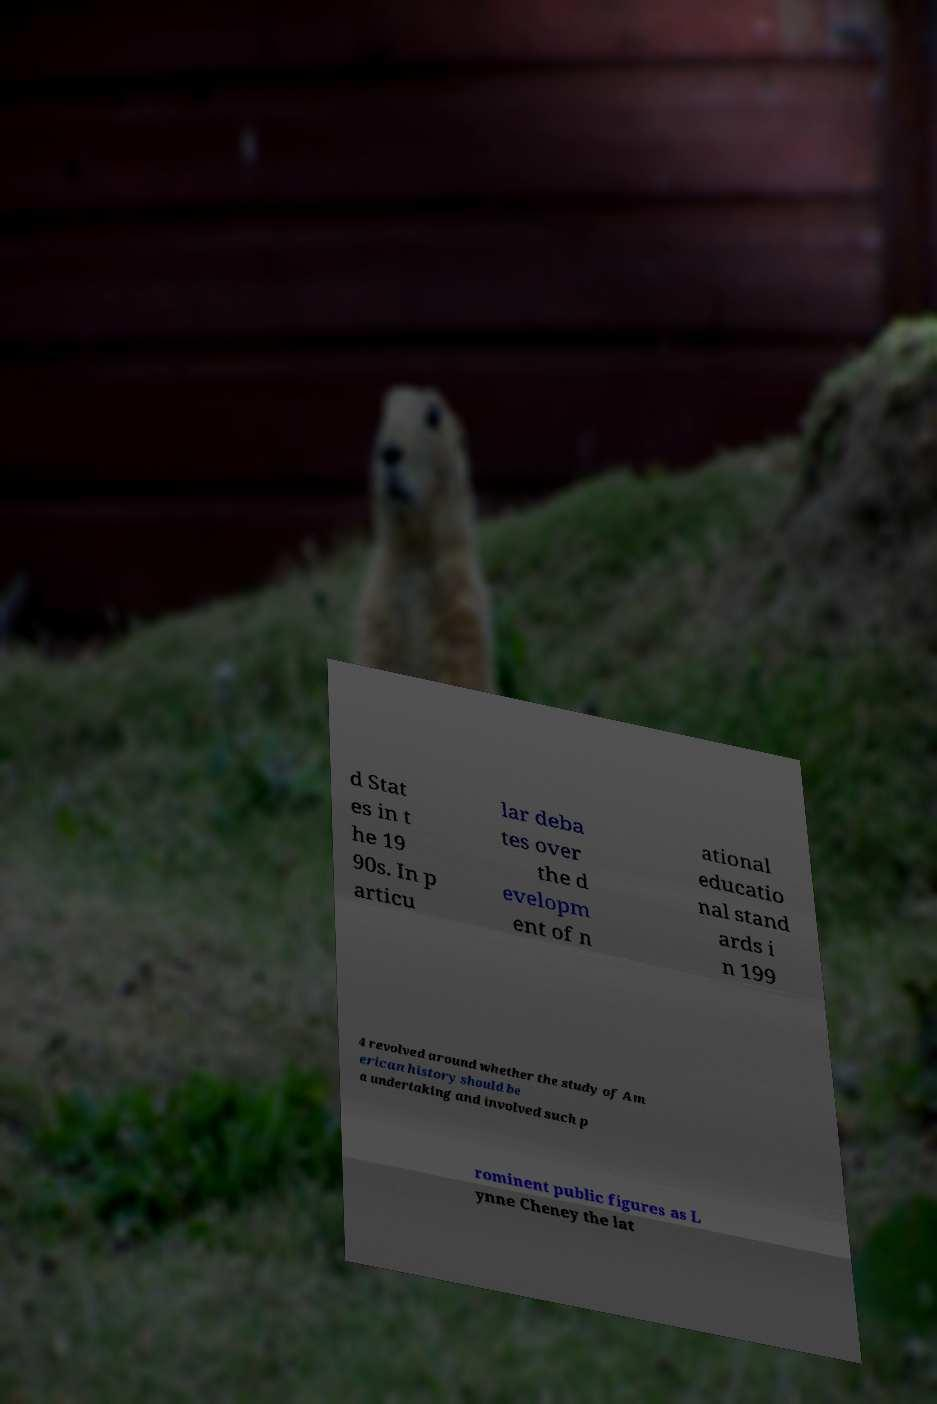Can you read and provide the text displayed in the image?This photo seems to have some interesting text. Can you extract and type it out for me? d Stat es in t he 19 90s. In p articu lar deba tes over the d evelopm ent of n ational educatio nal stand ards i n 199 4 revolved around whether the study of Am erican history should be a undertaking and involved such p rominent public figures as L ynne Cheney the lat 